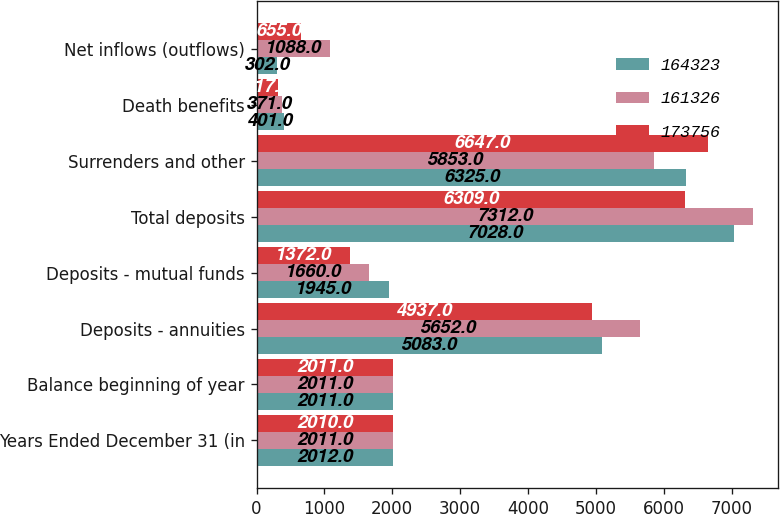Convert chart to OTSL. <chart><loc_0><loc_0><loc_500><loc_500><stacked_bar_chart><ecel><fcel>Years Ended December 31 (in<fcel>Balance beginning of year<fcel>Deposits - annuities<fcel>Deposits - mutual funds<fcel>Total deposits<fcel>Surrenders and other<fcel>Death benefits<fcel>Net inflows (outflows)<nl><fcel>164323<fcel>2012<fcel>2011<fcel>5083<fcel>1945<fcel>7028<fcel>6325<fcel>401<fcel>302<nl><fcel>161326<fcel>2011<fcel>2011<fcel>5652<fcel>1660<fcel>7312<fcel>5853<fcel>371<fcel>1088<nl><fcel>173756<fcel>2010<fcel>2011<fcel>4937<fcel>1372<fcel>6309<fcel>6647<fcel>317<fcel>655<nl></chart> 